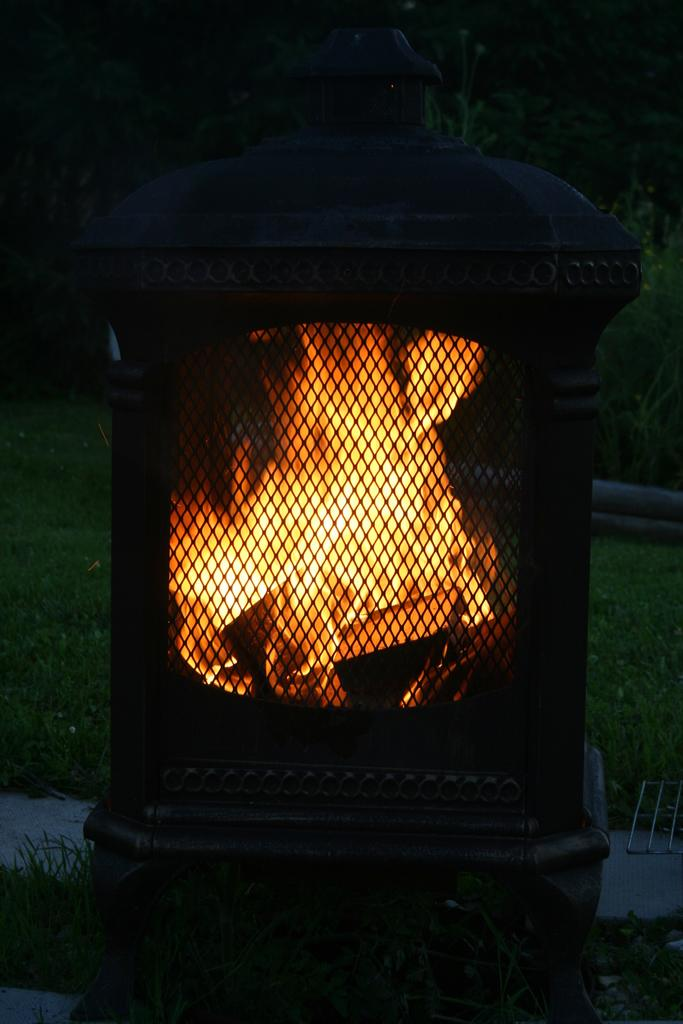What is the main feature of the image? There is a fireplace in the image. What can be seen in the background of the image? There is grass and trees in the background of the image. What team is playing in the image? There is no team playing in the image; it features a fireplace and a background with grass and trees. What type of lamp can be seen in the image? There is no lamp present in the image. 